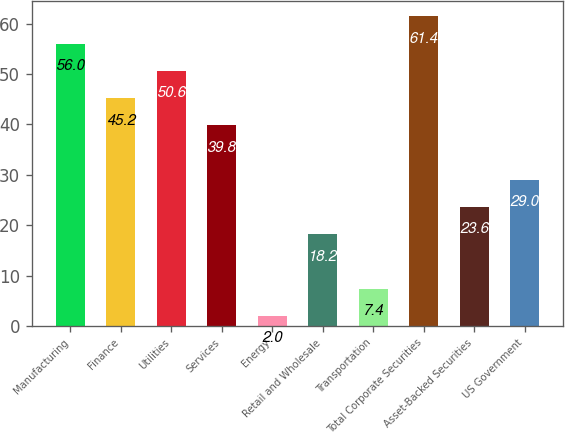Convert chart to OTSL. <chart><loc_0><loc_0><loc_500><loc_500><bar_chart><fcel>Manufacturing<fcel>Finance<fcel>Utilities<fcel>Services<fcel>Energy<fcel>Retail and Wholesale<fcel>Transportation<fcel>Total Corporate Securities<fcel>Asset-Backed Securities<fcel>US Government<nl><fcel>56<fcel>45.2<fcel>50.6<fcel>39.8<fcel>2<fcel>18.2<fcel>7.4<fcel>61.4<fcel>23.6<fcel>29<nl></chart> 